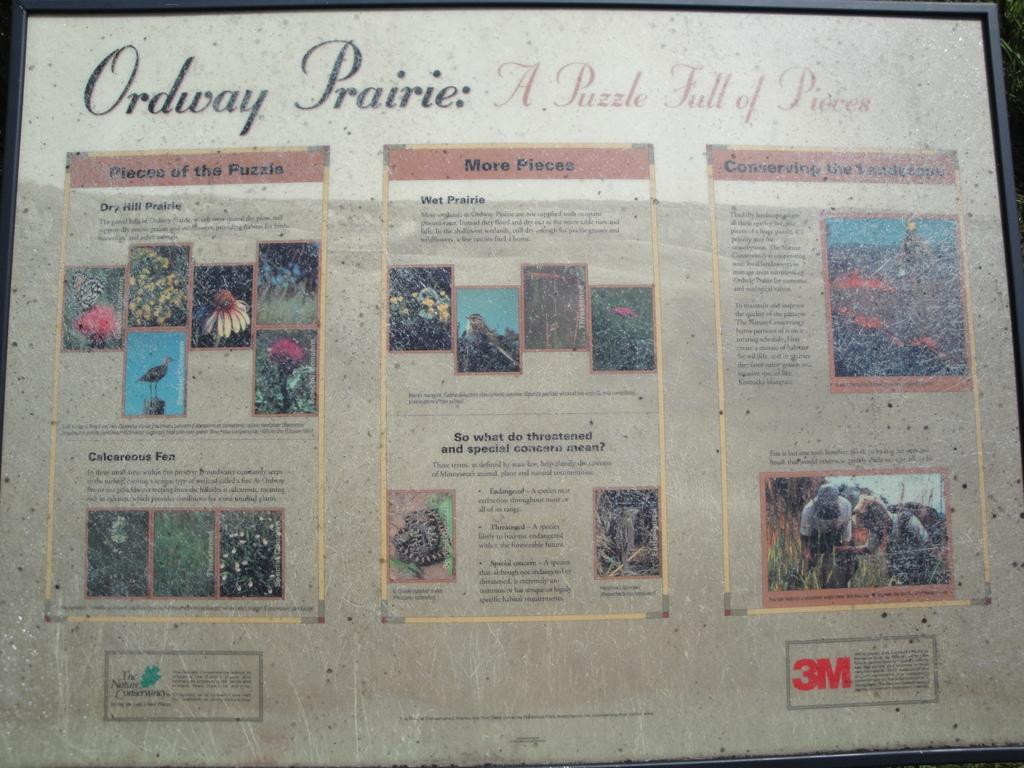Provide a one-sentence caption for the provided image. Ordway Prairie newspaper  A puzzle full of pieces. 